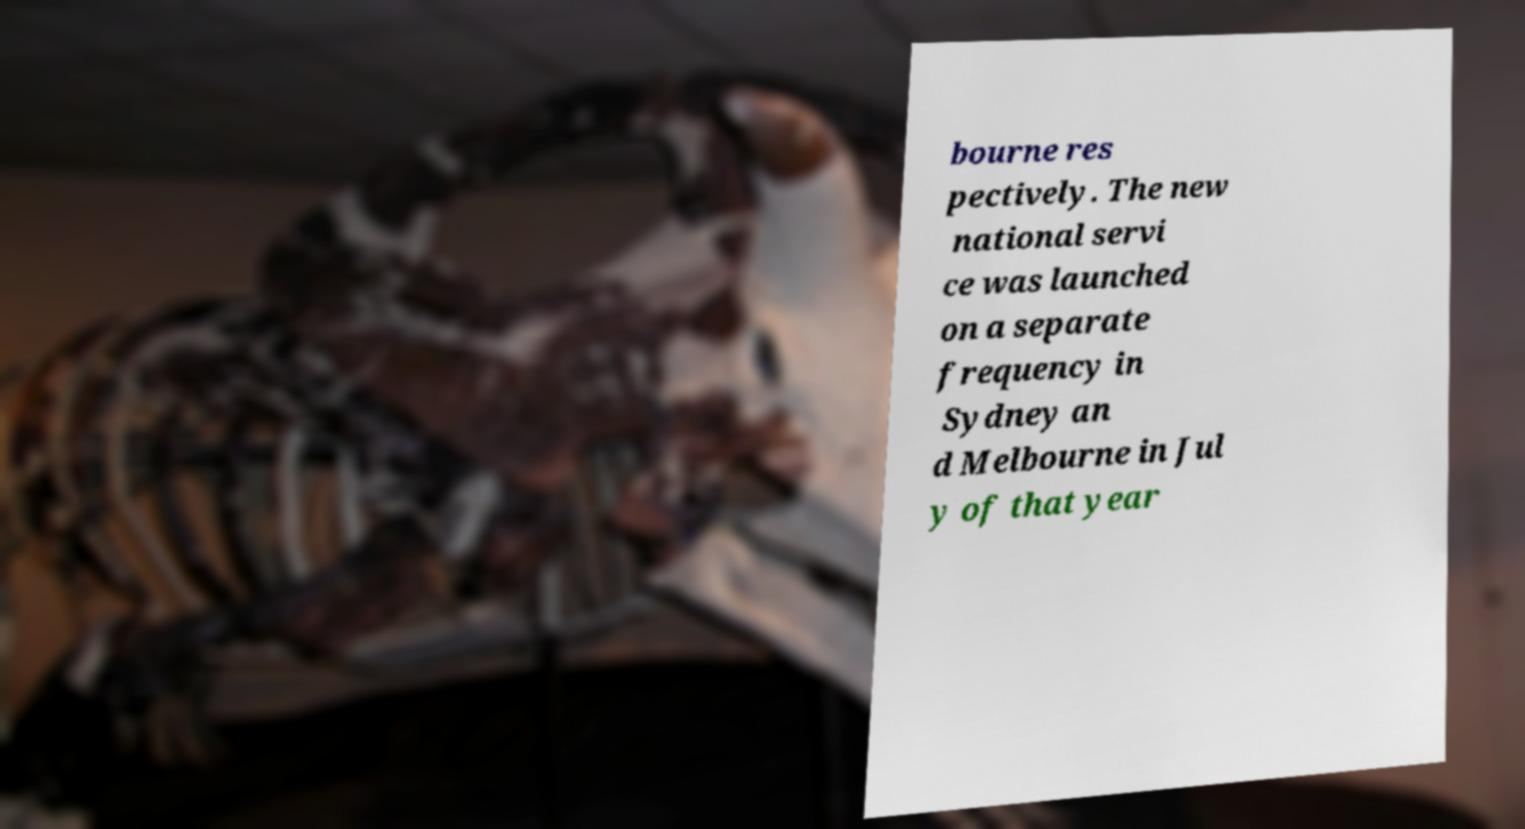Please read and relay the text visible in this image. What does it say? bourne res pectively. The new national servi ce was launched on a separate frequency in Sydney an d Melbourne in Jul y of that year 